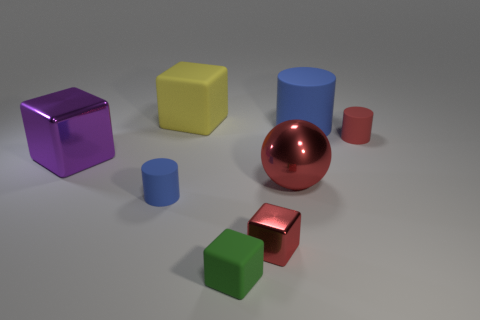Subtract 1 blocks. How many blocks are left? 3 Add 1 red blocks. How many objects exist? 9 Subtract all cylinders. How many objects are left? 5 Subtract 1 red cubes. How many objects are left? 7 Subtract all green blocks. Subtract all red objects. How many objects are left? 4 Add 6 big blue things. How many big blue things are left? 7 Add 8 tiny green matte blocks. How many tiny green matte blocks exist? 9 